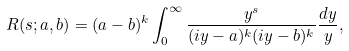<formula> <loc_0><loc_0><loc_500><loc_500>R ( s ; a , b ) = ( a - b ) ^ { k } \int _ { 0 } ^ { \infty } \frac { y ^ { s } } { ( i y - a ) ^ { k } ( i y - b ) ^ { k } } \frac { d y } { y } ,</formula> 